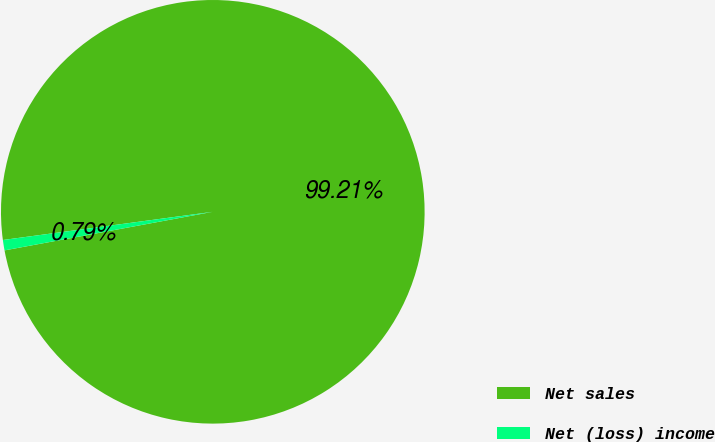<chart> <loc_0><loc_0><loc_500><loc_500><pie_chart><fcel>Net sales<fcel>Net (loss) income<nl><fcel>99.21%<fcel>0.79%<nl></chart> 